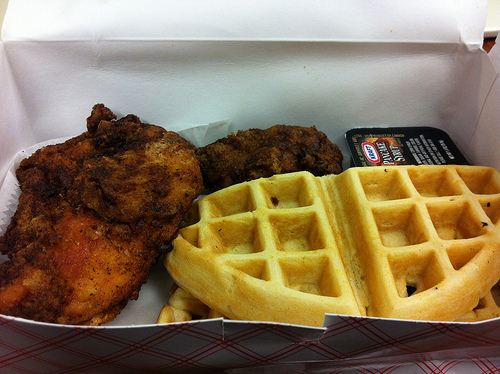<image>
Can you confirm if the pancake syrup is above the waffle? No. The pancake syrup is not positioned above the waffle. The vertical arrangement shows a different relationship. 